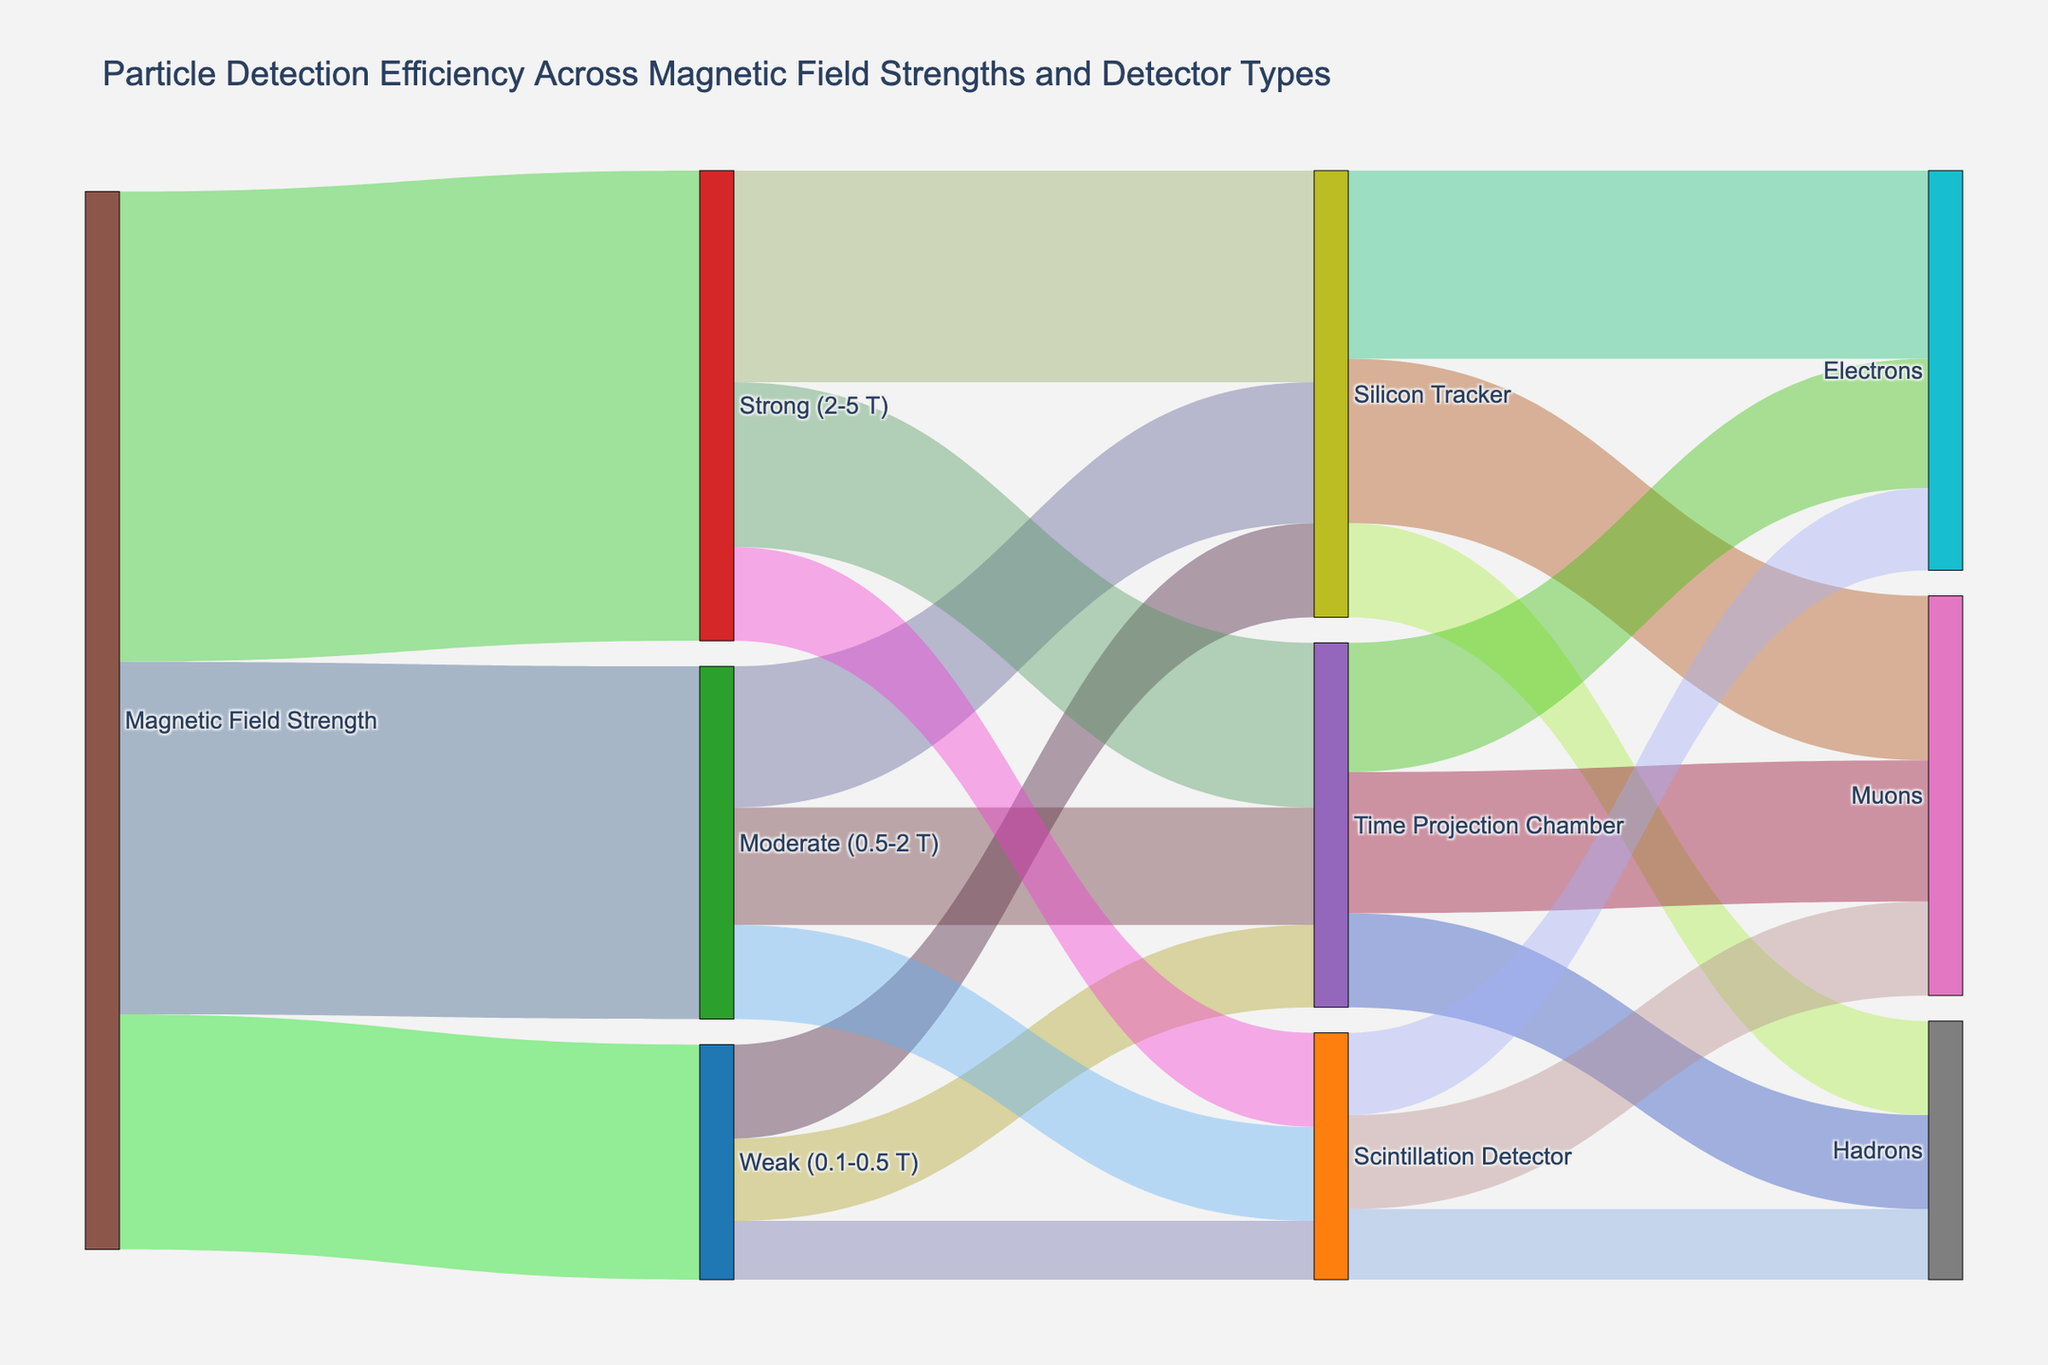What's the title of the figure? The title is typically located at the top center of the figure and gives a brief description of what the figure represents. In this case, the title is shown as "Particle Detection Efficiency Across Magnetic Field Strengths and Detector Types".
Answer: Particle Detection Efficiency Across Magnetic Field Strengths and Detector Types Which category of magnetic field strength has the highest value? By looking at the thickness of the flows and the numerical values represented, we can see that the "Strong (2-5 T)" category has the highest value, which is 200.
Answer: Strong (2-5 T) How many different types of detectors are used in the figure? There are three different types of detectors in the figure, which are indicated as separate nodes connecting from magnetic field strengths to particle types: "Silicon Tracker", "Time Projection Chamber", and "Scintillation Detector".
Answer: 3 Which detector type has the highest efficiency for detecting electrons? By following the links from each detector type to "Electrons", we can see the numerical values. The "Silicon Tracker" has the highest efficiency for detecting electrons with a value of 80.
Answer: Silicon Tracker Compare the efficiency of the Silicon Tracker in detecting Muons and Hadrons. Which one is higher and by how much? The efficiency of the Silicon Tracker for detecting Muons is 70 and for Hadrons is 40. Subtracting these values gives us 70 - 40 = 30, meaning the Silicon Tracker is more efficient in detecting Muons by 30 units.
Answer: Muons by 30 What is the total value of all detection efficiencies under the "Moderate (0.5-2 T)" magnetic field strength? Under "Moderate (0.5-2 T)", the values for detection efficiencies are 60 (Silicon Tracker), 50 (Time Projection Chamber), and 40 (Scintillation Detector). Summing these values gives 60 + 50 + 40 = 150.
Answer: 150 For the Time Projection Chamber, which particles does it detect and what are their combined values? The Time Projection Chamber detects Muons (60), Electrons (55), and Hadrons (40). Their combined value is 60 + 55 + 40 = 155.
Answer: Muons, Electrons, and Hadrons; combined value is 155 Which magnetic field strength category has the weakest (lowest) total value for the Scintillation Detector? By comparing the total values associated with the Scintillation Detector across different magnetic field strengths: 25 (Weak), 40 (Moderate), and 40 (Strong). The "Weak (0.1-0.5 T)" category has the lowest total value of 25.
Answer: Weak (0.1-0.5 T) What is the difference in detection efficiency for Electrons between the Silicon Tracker and Time Projection Chamber? The detection efficiency for Electrons is 80 for the Silicon Tracker and 55 for the Time Projection Chamber. The difference is 80 - 55 = 25.
Answer: 25 Considering all paths starting from "Weak (0.1-0.5 T)", what is the total particle detection output? The particle detection outputs from "Weak (0.1-0.5 T)" are summed as follows: Silicon Tracker (40), Time Projection Chamber (35), and Scintillation Detector (25). The total is 40 + 35 + 25 = 100.
Answer: 100 